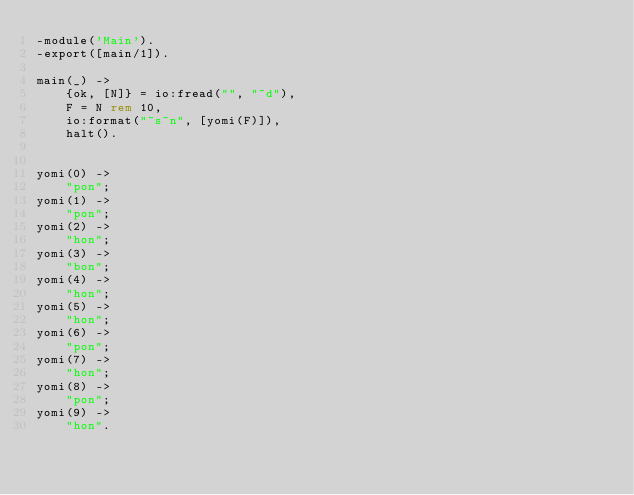Convert code to text. <code><loc_0><loc_0><loc_500><loc_500><_Erlang_>-module('Main').
-export([main/1]).

main(_) ->
    {ok, [N]} = io:fread("", "~d"),
    F = N rem 10,
    io:format("~s~n", [yomi(F)]),
    halt().


yomi(0) ->
    "pon";
yomi(1) ->
    "pon";
yomi(2) ->
    "hon";
yomi(3) ->
    "bon";
yomi(4) ->
    "hon";
yomi(5) ->
    "hon";
yomi(6) ->
    "pon";
yomi(7) ->
    "hon";
yomi(8) ->
    "pon";
yomi(9) ->
    "hon".
</code> 